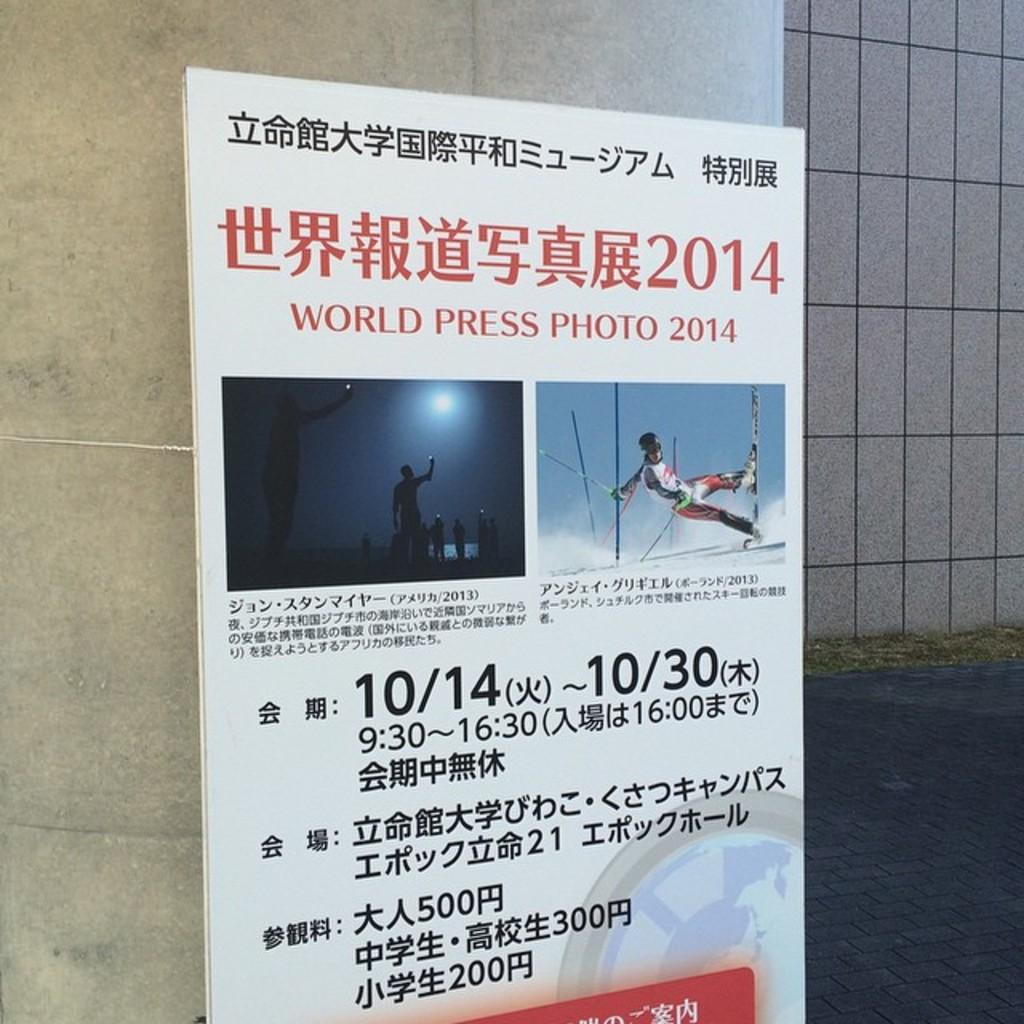Provide a one-sentence caption for the provided image. The World Press Photo 2014 show runs from 10/14-10/30. 